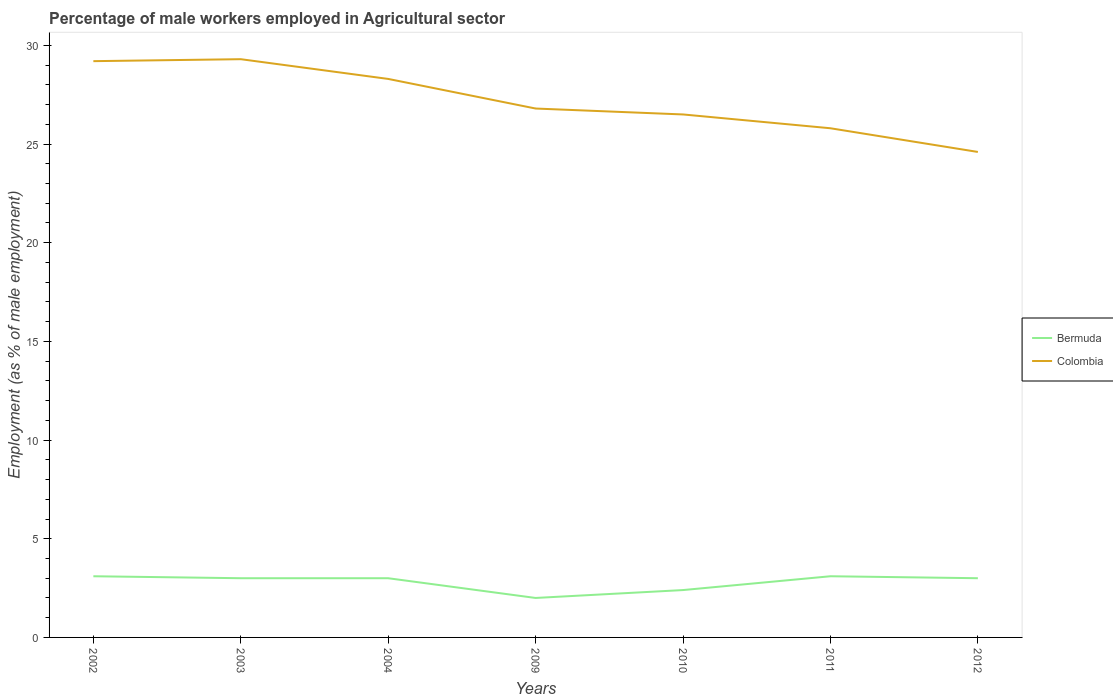How many different coloured lines are there?
Provide a short and direct response. 2. Does the line corresponding to Bermuda intersect with the line corresponding to Colombia?
Keep it short and to the point. No. Across all years, what is the maximum percentage of male workers employed in Agricultural sector in Colombia?
Provide a succinct answer. 24.6. What is the total percentage of male workers employed in Agricultural sector in Colombia in the graph?
Your answer should be compact. 3.7. What is the difference between the highest and the second highest percentage of male workers employed in Agricultural sector in Colombia?
Give a very brief answer. 4.7. What is the difference between the highest and the lowest percentage of male workers employed in Agricultural sector in Bermuda?
Make the answer very short. 5. Is the percentage of male workers employed in Agricultural sector in Bermuda strictly greater than the percentage of male workers employed in Agricultural sector in Colombia over the years?
Give a very brief answer. Yes. How many lines are there?
Keep it short and to the point. 2. How many years are there in the graph?
Offer a very short reply. 7. Does the graph contain grids?
Keep it short and to the point. No. Where does the legend appear in the graph?
Offer a very short reply. Center right. How many legend labels are there?
Provide a succinct answer. 2. How are the legend labels stacked?
Your answer should be very brief. Vertical. What is the title of the graph?
Your answer should be very brief. Percentage of male workers employed in Agricultural sector. Does "Lesotho" appear as one of the legend labels in the graph?
Offer a very short reply. No. What is the label or title of the X-axis?
Offer a terse response. Years. What is the label or title of the Y-axis?
Give a very brief answer. Employment (as % of male employment). What is the Employment (as % of male employment) in Bermuda in 2002?
Your answer should be compact. 3.1. What is the Employment (as % of male employment) of Colombia in 2002?
Your answer should be very brief. 29.2. What is the Employment (as % of male employment) in Colombia in 2003?
Your answer should be very brief. 29.3. What is the Employment (as % of male employment) of Colombia in 2004?
Offer a very short reply. 28.3. What is the Employment (as % of male employment) of Colombia in 2009?
Provide a short and direct response. 26.8. What is the Employment (as % of male employment) of Bermuda in 2010?
Keep it short and to the point. 2.4. What is the Employment (as % of male employment) in Bermuda in 2011?
Your answer should be very brief. 3.1. What is the Employment (as % of male employment) in Colombia in 2011?
Your answer should be compact. 25.8. What is the Employment (as % of male employment) of Bermuda in 2012?
Give a very brief answer. 3. What is the Employment (as % of male employment) of Colombia in 2012?
Your response must be concise. 24.6. Across all years, what is the maximum Employment (as % of male employment) in Bermuda?
Provide a short and direct response. 3.1. Across all years, what is the maximum Employment (as % of male employment) of Colombia?
Keep it short and to the point. 29.3. Across all years, what is the minimum Employment (as % of male employment) of Colombia?
Offer a terse response. 24.6. What is the total Employment (as % of male employment) of Bermuda in the graph?
Your answer should be very brief. 19.6. What is the total Employment (as % of male employment) of Colombia in the graph?
Give a very brief answer. 190.5. What is the difference between the Employment (as % of male employment) in Bermuda in 2002 and that in 2003?
Provide a short and direct response. 0.1. What is the difference between the Employment (as % of male employment) in Colombia in 2002 and that in 2003?
Give a very brief answer. -0.1. What is the difference between the Employment (as % of male employment) of Bermuda in 2002 and that in 2004?
Offer a terse response. 0.1. What is the difference between the Employment (as % of male employment) in Bermuda in 2002 and that in 2010?
Keep it short and to the point. 0.7. What is the difference between the Employment (as % of male employment) in Bermuda in 2002 and that in 2012?
Make the answer very short. 0.1. What is the difference between the Employment (as % of male employment) in Colombia in 2003 and that in 2004?
Your answer should be very brief. 1. What is the difference between the Employment (as % of male employment) of Colombia in 2003 and that in 2009?
Provide a short and direct response. 2.5. What is the difference between the Employment (as % of male employment) of Bermuda in 2003 and that in 2011?
Give a very brief answer. -0.1. What is the difference between the Employment (as % of male employment) in Colombia in 2003 and that in 2011?
Offer a very short reply. 3.5. What is the difference between the Employment (as % of male employment) of Colombia in 2003 and that in 2012?
Ensure brevity in your answer.  4.7. What is the difference between the Employment (as % of male employment) of Colombia in 2004 and that in 2009?
Make the answer very short. 1.5. What is the difference between the Employment (as % of male employment) in Bermuda in 2004 and that in 2010?
Provide a succinct answer. 0.6. What is the difference between the Employment (as % of male employment) in Colombia in 2004 and that in 2010?
Provide a succinct answer. 1.8. What is the difference between the Employment (as % of male employment) of Colombia in 2004 and that in 2011?
Your answer should be compact. 2.5. What is the difference between the Employment (as % of male employment) in Bermuda in 2009 and that in 2010?
Keep it short and to the point. -0.4. What is the difference between the Employment (as % of male employment) in Colombia in 2009 and that in 2010?
Your answer should be compact. 0.3. What is the difference between the Employment (as % of male employment) of Bermuda in 2009 and that in 2011?
Provide a short and direct response. -1.1. What is the difference between the Employment (as % of male employment) in Bermuda in 2010 and that in 2011?
Keep it short and to the point. -0.7. What is the difference between the Employment (as % of male employment) in Colombia in 2010 and that in 2011?
Provide a succinct answer. 0.7. What is the difference between the Employment (as % of male employment) in Colombia in 2010 and that in 2012?
Offer a very short reply. 1.9. What is the difference between the Employment (as % of male employment) of Colombia in 2011 and that in 2012?
Ensure brevity in your answer.  1.2. What is the difference between the Employment (as % of male employment) of Bermuda in 2002 and the Employment (as % of male employment) of Colombia in 2003?
Your answer should be very brief. -26.2. What is the difference between the Employment (as % of male employment) in Bermuda in 2002 and the Employment (as % of male employment) in Colombia in 2004?
Your answer should be compact. -25.2. What is the difference between the Employment (as % of male employment) of Bermuda in 2002 and the Employment (as % of male employment) of Colombia in 2009?
Offer a very short reply. -23.7. What is the difference between the Employment (as % of male employment) of Bermuda in 2002 and the Employment (as % of male employment) of Colombia in 2010?
Provide a succinct answer. -23.4. What is the difference between the Employment (as % of male employment) of Bermuda in 2002 and the Employment (as % of male employment) of Colombia in 2011?
Your answer should be very brief. -22.7. What is the difference between the Employment (as % of male employment) in Bermuda in 2002 and the Employment (as % of male employment) in Colombia in 2012?
Your response must be concise. -21.5. What is the difference between the Employment (as % of male employment) in Bermuda in 2003 and the Employment (as % of male employment) in Colombia in 2004?
Your response must be concise. -25.3. What is the difference between the Employment (as % of male employment) in Bermuda in 2003 and the Employment (as % of male employment) in Colombia in 2009?
Ensure brevity in your answer.  -23.8. What is the difference between the Employment (as % of male employment) in Bermuda in 2003 and the Employment (as % of male employment) in Colombia in 2010?
Ensure brevity in your answer.  -23.5. What is the difference between the Employment (as % of male employment) of Bermuda in 2003 and the Employment (as % of male employment) of Colombia in 2011?
Provide a short and direct response. -22.8. What is the difference between the Employment (as % of male employment) in Bermuda in 2003 and the Employment (as % of male employment) in Colombia in 2012?
Your response must be concise. -21.6. What is the difference between the Employment (as % of male employment) of Bermuda in 2004 and the Employment (as % of male employment) of Colombia in 2009?
Offer a terse response. -23.8. What is the difference between the Employment (as % of male employment) of Bermuda in 2004 and the Employment (as % of male employment) of Colombia in 2010?
Your answer should be compact. -23.5. What is the difference between the Employment (as % of male employment) of Bermuda in 2004 and the Employment (as % of male employment) of Colombia in 2011?
Ensure brevity in your answer.  -22.8. What is the difference between the Employment (as % of male employment) in Bermuda in 2004 and the Employment (as % of male employment) in Colombia in 2012?
Provide a short and direct response. -21.6. What is the difference between the Employment (as % of male employment) of Bermuda in 2009 and the Employment (as % of male employment) of Colombia in 2010?
Ensure brevity in your answer.  -24.5. What is the difference between the Employment (as % of male employment) in Bermuda in 2009 and the Employment (as % of male employment) in Colombia in 2011?
Provide a short and direct response. -23.8. What is the difference between the Employment (as % of male employment) in Bermuda in 2009 and the Employment (as % of male employment) in Colombia in 2012?
Provide a short and direct response. -22.6. What is the difference between the Employment (as % of male employment) of Bermuda in 2010 and the Employment (as % of male employment) of Colombia in 2011?
Your answer should be very brief. -23.4. What is the difference between the Employment (as % of male employment) in Bermuda in 2010 and the Employment (as % of male employment) in Colombia in 2012?
Your response must be concise. -22.2. What is the difference between the Employment (as % of male employment) of Bermuda in 2011 and the Employment (as % of male employment) of Colombia in 2012?
Ensure brevity in your answer.  -21.5. What is the average Employment (as % of male employment) in Bermuda per year?
Your answer should be compact. 2.8. What is the average Employment (as % of male employment) in Colombia per year?
Provide a short and direct response. 27.21. In the year 2002, what is the difference between the Employment (as % of male employment) in Bermuda and Employment (as % of male employment) in Colombia?
Ensure brevity in your answer.  -26.1. In the year 2003, what is the difference between the Employment (as % of male employment) in Bermuda and Employment (as % of male employment) in Colombia?
Keep it short and to the point. -26.3. In the year 2004, what is the difference between the Employment (as % of male employment) of Bermuda and Employment (as % of male employment) of Colombia?
Ensure brevity in your answer.  -25.3. In the year 2009, what is the difference between the Employment (as % of male employment) in Bermuda and Employment (as % of male employment) in Colombia?
Your answer should be very brief. -24.8. In the year 2010, what is the difference between the Employment (as % of male employment) of Bermuda and Employment (as % of male employment) of Colombia?
Provide a succinct answer. -24.1. In the year 2011, what is the difference between the Employment (as % of male employment) of Bermuda and Employment (as % of male employment) of Colombia?
Provide a short and direct response. -22.7. In the year 2012, what is the difference between the Employment (as % of male employment) of Bermuda and Employment (as % of male employment) of Colombia?
Offer a very short reply. -21.6. What is the ratio of the Employment (as % of male employment) of Colombia in 2002 to that in 2003?
Your response must be concise. 1. What is the ratio of the Employment (as % of male employment) in Bermuda in 2002 to that in 2004?
Provide a succinct answer. 1.03. What is the ratio of the Employment (as % of male employment) of Colombia in 2002 to that in 2004?
Your answer should be very brief. 1.03. What is the ratio of the Employment (as % of male employment) in Bermuda in 2002 to that in 2009?
Your response must be concise. 1.55. What is the ratio of the Employment (as % of male employment) of Colombia in 2002 to that in 2009?
Offer a very short reply. 1.09. What is the ratio of the Employment (as % of male employment) in Bermuda in 2002 to that in 2010?
Make the answer very short. 1.29. What is the ratio of the Employment (as % of male employment) in Colombia in 2002 to that in 2010?
Ensure brevity in your answer.  1.1. What is the ratio of the Employment (as % of male employment) in Bermuda in 2002 to that in 2011?
Offer a very short reply. 1. What is the ratio of the Employment (as % of male employment) in Colombia in 2002 to that in 2011?
Keep it short and to the point. 1.13. What is the ratio of the Employment (as % of male employment) of Bermuda in 2002 to that in 2012?
Make the answer very short. 1.03. What is the ratio of the Employment (as % of male employment) in Colombia in 2002 to that in 2012?
Keep it short and to the point. 1.19. What is the ratio of the Employment (as % of male employment) of Colombia in 2003 to that in 2004?
Your answer should be compact. 1.04. What is the ratio of the Employment (as % of male employment) in Colombia in 2003 to that in 2009?
Keep it short and to the point. 1.09. What is the ratio of the Employment (as % of male employment) of Colombia in 2003 to that in 2010?
Give a very brief answer. 1.11. What is the ratio of the Employment (as % of male employment) of Colombia in 2003 to that in 2011?
Your answer should be very brief. 1.14. What is the ratio of the Employment (as % of male employment) in Bermuda in 2003 to that in 2012?
Make the answer very short. 1. What is the ratio of the Employment (as % of male employment) in Colombia in 2003 to that in 2012?
Give a very brief answer. 1.19. What is the ratio of the Employment (as % of male employment) in Colombia in 2004 to that in 2009?
Your answer should be very brief. 1.06. What is the ratio of the Employment (as % of male employment) in Bermuda in 2004 to that in 2010?
Provide a succinct answer. 1.25. What is the ratio of the Employment (as % of male employment) of Colombia in 2004 to that in 2010?
Ensure brevity in your answer.  1.07. What is the ratio of the Employment (as % of male employment) in Bermuda in 2004 to that in 2011?
Offer a very short reply. 0.97. What is the ratio of the Employment (as % of male employment) of Colombia in 2004 to that in 2011?
Ensure brevity in your answer.  1.1. What is the ratio of the Employment (as % of male employment) of Colombia in 2004 to that in 2012?
Your answer should be very brief. 1.15. What is the ratio of the Employment (as % of male employment) of Bermuda in 2009 to that in 2010?
Offer a very short reply. 0.83. What is the ratio of the Employment (as % of male employment) of Colombia in 2009 to that in 2010?
Make the answer very short. 1.01. What is the ratio of the Employment (as % of male employment) in Bermuda in 2009 to that in 2011?
Offer a very short reply. 0.65. What is the ratio of the Employment (as % of male employment) in Colombia in 2009 to that in 2011?
Give a very brief answer. 1.04. What is the ratio of the Employment (as % of male employment) in Colombia in 2009 to that in 2012?
Your response must be concise. 1.09. What is the ratio of the Employment (as % of male employment) of Bermuda in 2010 to that in 2011?
Offer a terse response. 0.77. What is the ratio of the Employment (as % of male employment) of Colombia in 2010 to that in 2011?
Provide a short and direct response. 1.03. What is the ratio of the Employment (as % of male employment) in Bermuda in 2010 to that in 2012?
Offer a very short reply. 0.8. What is the ratio of the Employment (as % of male employment) of Colombia in 2010 to that in 2012?
Give a very brief answer. 1.08. What is the ratio of the Employment (as % of male employment) in Colombia in 2011 to that in 2012?
Offer a very short reply. 1.05. What is the difference between the highest and the second highest Employment (as % of male employment) in Bermuda?
Provide a short and direct response. 0. What is the difference between the highest and the second highest Employment (as % of male employment) of Colombia?
Make the answer very short. 0.1. What is the difference between the highest and the lowest Employment (as % of male employment) of Bermuda?
Provide a succinct answer. 1.1. What is the difference between the highest and the lowest Employment (as % of male employment) in Colombia?
Keep it short and to the point. 4.7. 